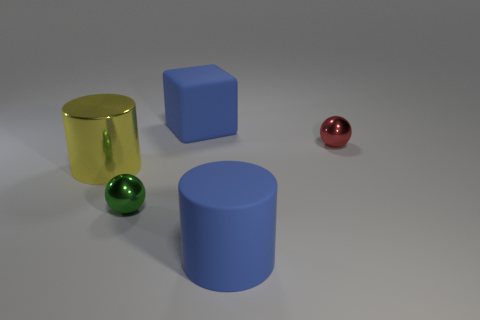Subtract all purple cylinders. Subtract all green spheres. How many cylinders are left? 2 Add 5 big blue rubber cubes. How many objects exist? 10 Subtract all cylinders. How many objects are left? 3 Add 1 yellow metallic objects. How many yellow metallic objects exist? 2 Subtract 0 brown spheres. How many objects are left? 5 Subtract all big blue matte things. Subtract all large blue blocks. How many objects are left? 2 Add 5 blue cubes. How many blue cubes are left? 6 